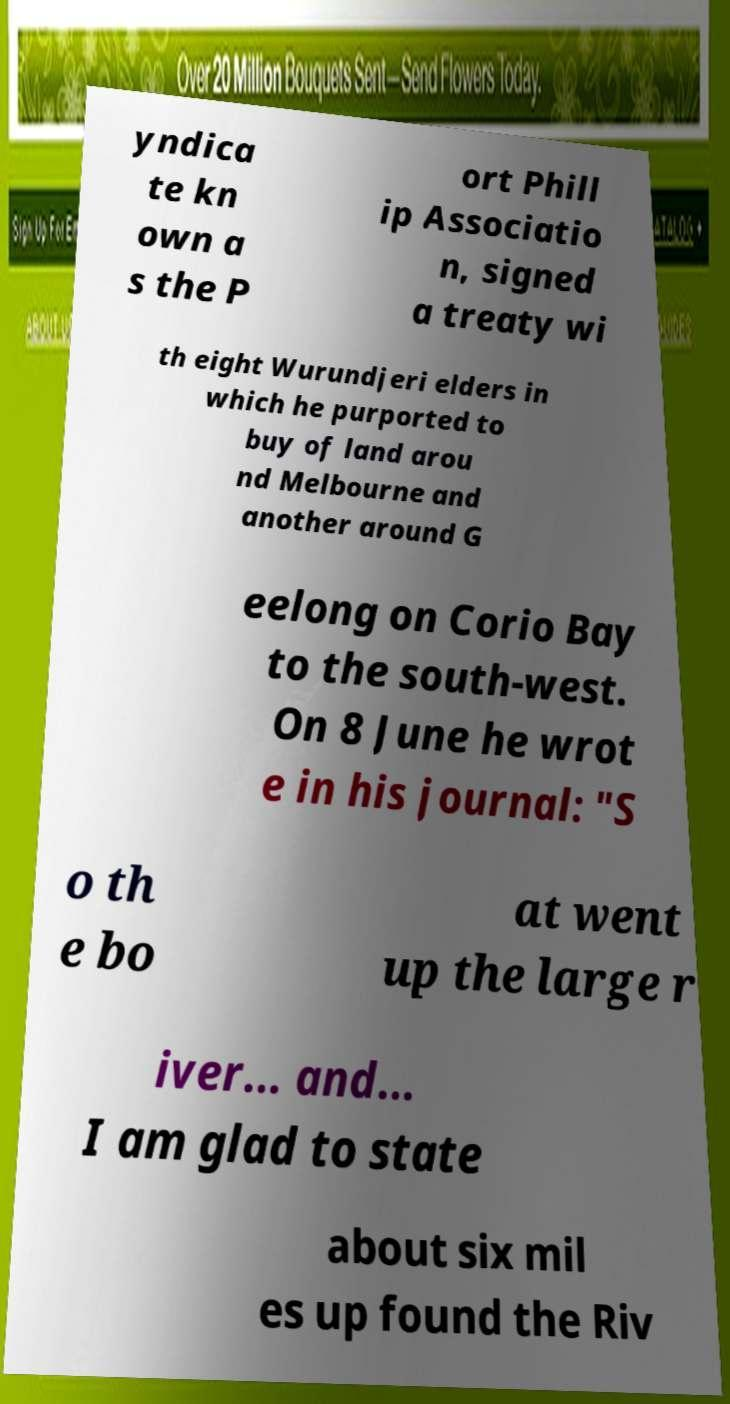Can you read and provide the text displayed in the image?This photo seems to have some interesting text. Can you extract and type it out for me? yndica te kn own a s the P ort Phill ip Associatio n, signed a treaty wi th eight Wurundjeri elders in which he purported to buy of land arou nd Melbourne and another around G eelong on Corio Bay to the south-west. On 8 June he wrot e in his journal: "S o th e bo at went up the large r iver... and... I am glad to state about six mil es up found the Riv 